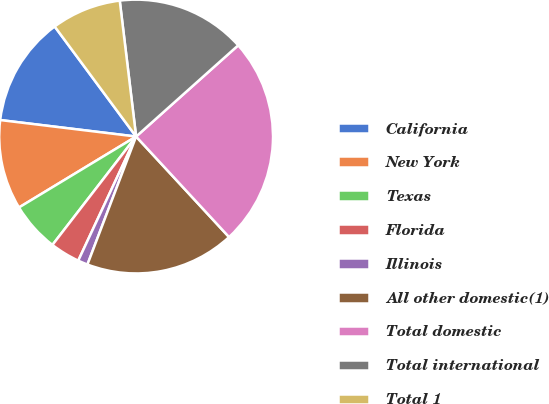Convert chart. <chart><loc_0><loc_0><loc_500><loc_500><pie_chart><fcel>California<fcel>New York<fcel>Texas<fcel>Florida<fcel>Illinois<fcel>All other domestic(1)<fcel>Total domestic<fcel>Total international<fcel>Total 1<nl><fcel>12.94%<fcel>10.59%<fcel>5.87%<fcel>3.52%<fcel>1.16%<fcel>17.66%<fcel>24.73%<fcel>15.3%<fcel>8.23%<nl></chart> 